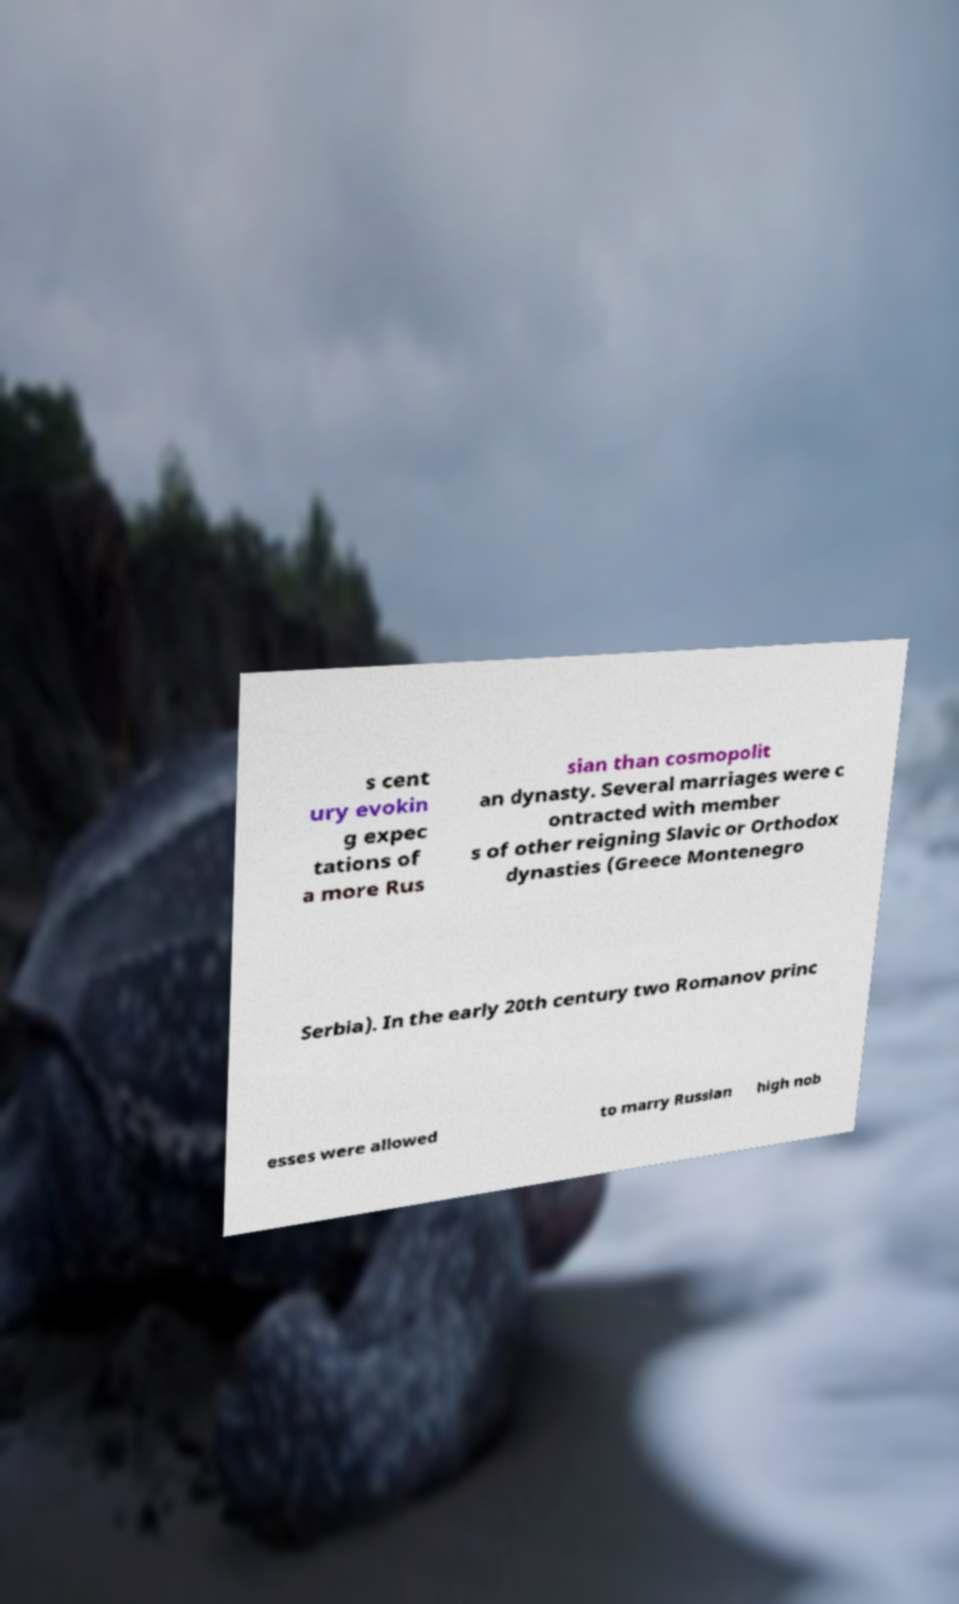For documentation purposes, I need the text within this image transcribed. Could you provide that? s cent ury evokin g expec tations of a more Rus sian than cosmopolit an dynasty. Several marriages were c ontracted with member s of other reigning Slavic or Orthodox dynasties (Greece Montenegro Serbia). In the early 20th century two Romanov princ esses were allowed to marry Russian high nob 